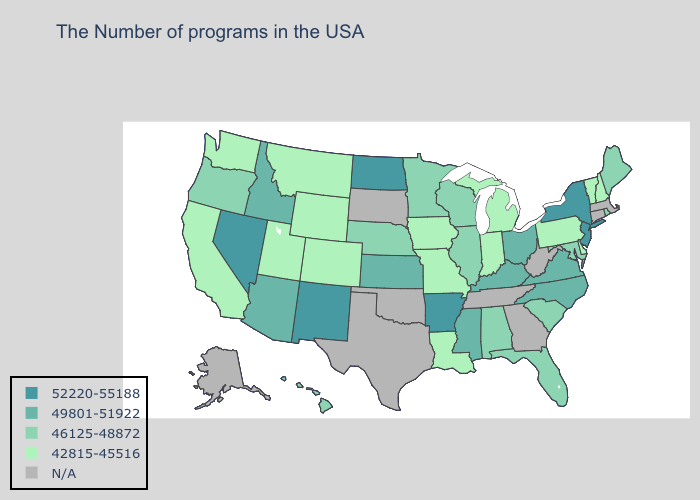What is the value of Missouri?
Quick response, please. 42815-45516. Name the states that have a value in the range 42815-45516?
Answer briefly. New Hampshire, Vermont, Delaware, Pennsylvania, Michigan, Indiana, Louisiana, Missouri, Iowa, Wyoming, Colorado, Utah, Montana, California, Washington. Name the states that have a value in the range 52220-55188?
Short answer required. New York, New Jersey, Arkansas, North Dakota, New Mexico, Nevada. Does the first symbol in the legend represent the smallest category?
Be succinct. No. Among the states that border New Jersey , which have the highest value?
Give a very brief answer. New York. Name the states that have a value in the range 42815-45516?
Quick response, please. New Hampshire, Vermont, Delaware, Pennsylvania, Michigan, Indiana, Louisiana, Missouri, Iowa, Wyoming, Colorado, Utah, Montana, California, Washington. Does Maryland have the lowest value in the USA?
Be succinct. No. Among the states that border Idaho , does Nevada have the highest value?
Write a very short answer. Yes. Does the map have missing data?
Quick response, please. Yes. Name the states that have a value in the range N/A?
Short answer required. Massachusetts, Connecticut, West Virginia, Georgia, Tennessee, Oklahoma, Texas, South Dakota, Alaska. What is the value of Maine?
Keep it brief. 46125-48872. What is the value of Mississippi?
Keep it brief. 49801-51922. Which states have the lowest value in the USA?
Write a very short answer. New Hampshire, Vermont, Delaware, Pennsylvania, Michigan, Indiana, Louisiana, Missouri, Iowa, Wyoming, Colorado, Utah, Montana, California, Washington. What is the value of Minnesota?
Short answer required. 46125-48872. Does the first symbol in the legend represent the smallest category?
Be succinct. No. 